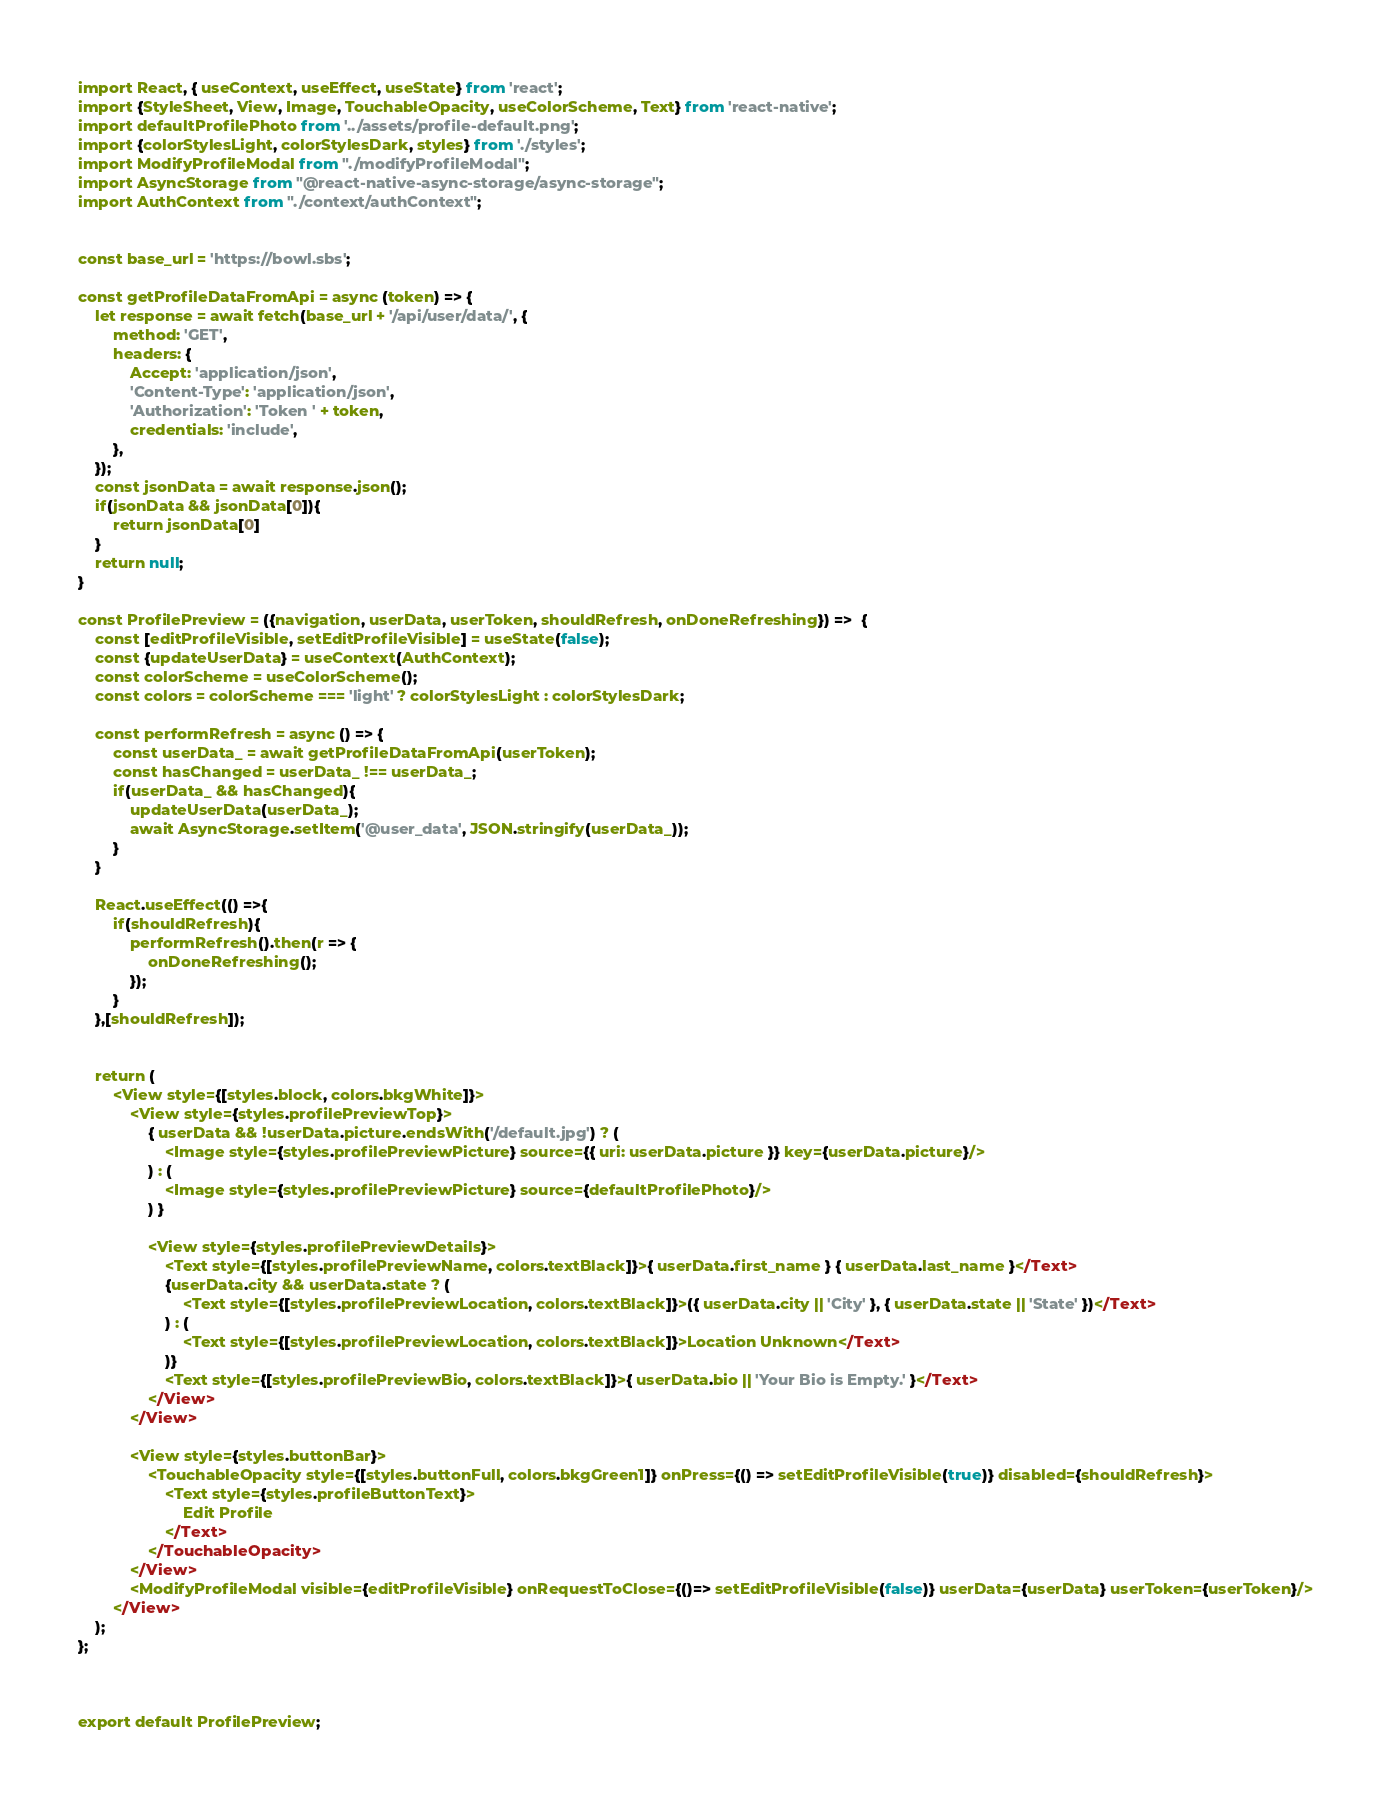<code> <loc_0><loc_0><loc_500><loc_500><_JavaScript_>import React, { useContext, useEffect, useState} from 'react';
import {StyleSheet, View, Image, TouchableOpacity, useColorScheme, Text} from 'react-native';
import defaultProfilePhoto from '../assets/profile-default.png';
import {colorStylesLight, colorStylesDark, styles} from './styles';
import ModifyProfileModal from "./modifyProfileModal";
import AsyncStorage from "@react-native-async-storage/async-storage";
import AuthContext from "./context/authContext";


const base_url = 'https://bowl.sbs';

const getProfileDataFromApi = async (token) => {
    let response = await fetch(base_url + '/api/user/data/', {
        method: 'GET',
        headers: {
            Accept: 'application/json',
            'Content-Type': 'application/json',
            'Authorization': 'Token ' + token,
            credentials: 'include',
        },
    });
    const jsonData = await response.json();
    if(jsonData && jsonData[0]){
        return jsonData[0]
    }
    return null;
}

const ProfilePreview = ({navigation, userData, userToken, shouldRefresh, onDoneRefreshing}) =>  {
    const [editProfileVisible, setEditProfileVisible] = useState(false);
    const {updateUserData} = useContext(AuthContext);
    const colorScheme = useColorScheme();
    const colors = colorScheme === 'light' ? colorStylesLight : colorStylesDark;

    const performRefresh = async () => {
        const userData_ = await getProfileDataFromApi(userToken);
        const hasChanged = userData_ !== userData_;
        if(userData_ && hasChanged){
            updateUserData(userData_);
            await AsyncStorage.setItem('@user_data', JSON.stringify(userData_));
        }
    }

    React.useEffect(() =>{
        if(shouldRefresh){
            performRefresh().then(r => {
                onDoneRefreshing();
            });
        }
    },[shouldRefresh]);


    return (
        <View style={[styles.block, colors.bkgWhite]}>
            <View style={styles.profilePreviewTop}>
                { userData && !userData.picture.endsWith('/default.jpg') ? (
                    <Image style={styles.profilePreviewPicture} source={{ uri: userData.picture }} key={userData.picture}/>
                ) : (
                    <Image style={styles.profilePreviewPicture} source={defaultProfilePhoto}/>
                ) }

                <View style={styles.profilePreviewDetails}>
                    <Text style={[styles.profilePreviewName, colors.textBlack]}>{ userData.first_name } { userData.last_name }</Text>
                    {userData.city && userData.state ? (
                        <Text style={[styles.profilePreviewLocation, colors.textBlack]}>({ userData.city || 'City' }, { userData.state || 'State' })</Text>
                    ) : (
                        <Text style={[styles.profilePreviewLocation, colors.textBlack]}>Location Unknown</Text>
                    )}
                    <Text style={[styles.profilePreviewBio, colors.textBlack]}>{ userData.bio || 'Your Bio is Empty.' }</Text>
                </View>
            </View>

            <View style={styles.buttonBar}>
                <TouchableOpacity style={[styles.buttonFull, colors.bkgGreen1]} onPress={() => setEditProfileVisible(true)} disabled={shouldRefresh}>
                    <Text style={styles.profileButtonText}>
                        Edit Profile
                    </Text>
                </TouchableOpacity>
            </View>
            <ModifyProfileModal visible={editProfileVisible} onRequestToClose={()=> setEditProfileVisible(false)} userData={userData} userToken={userToken}/>
        </View>
    );
};



export default ProfilePreview;</code> 